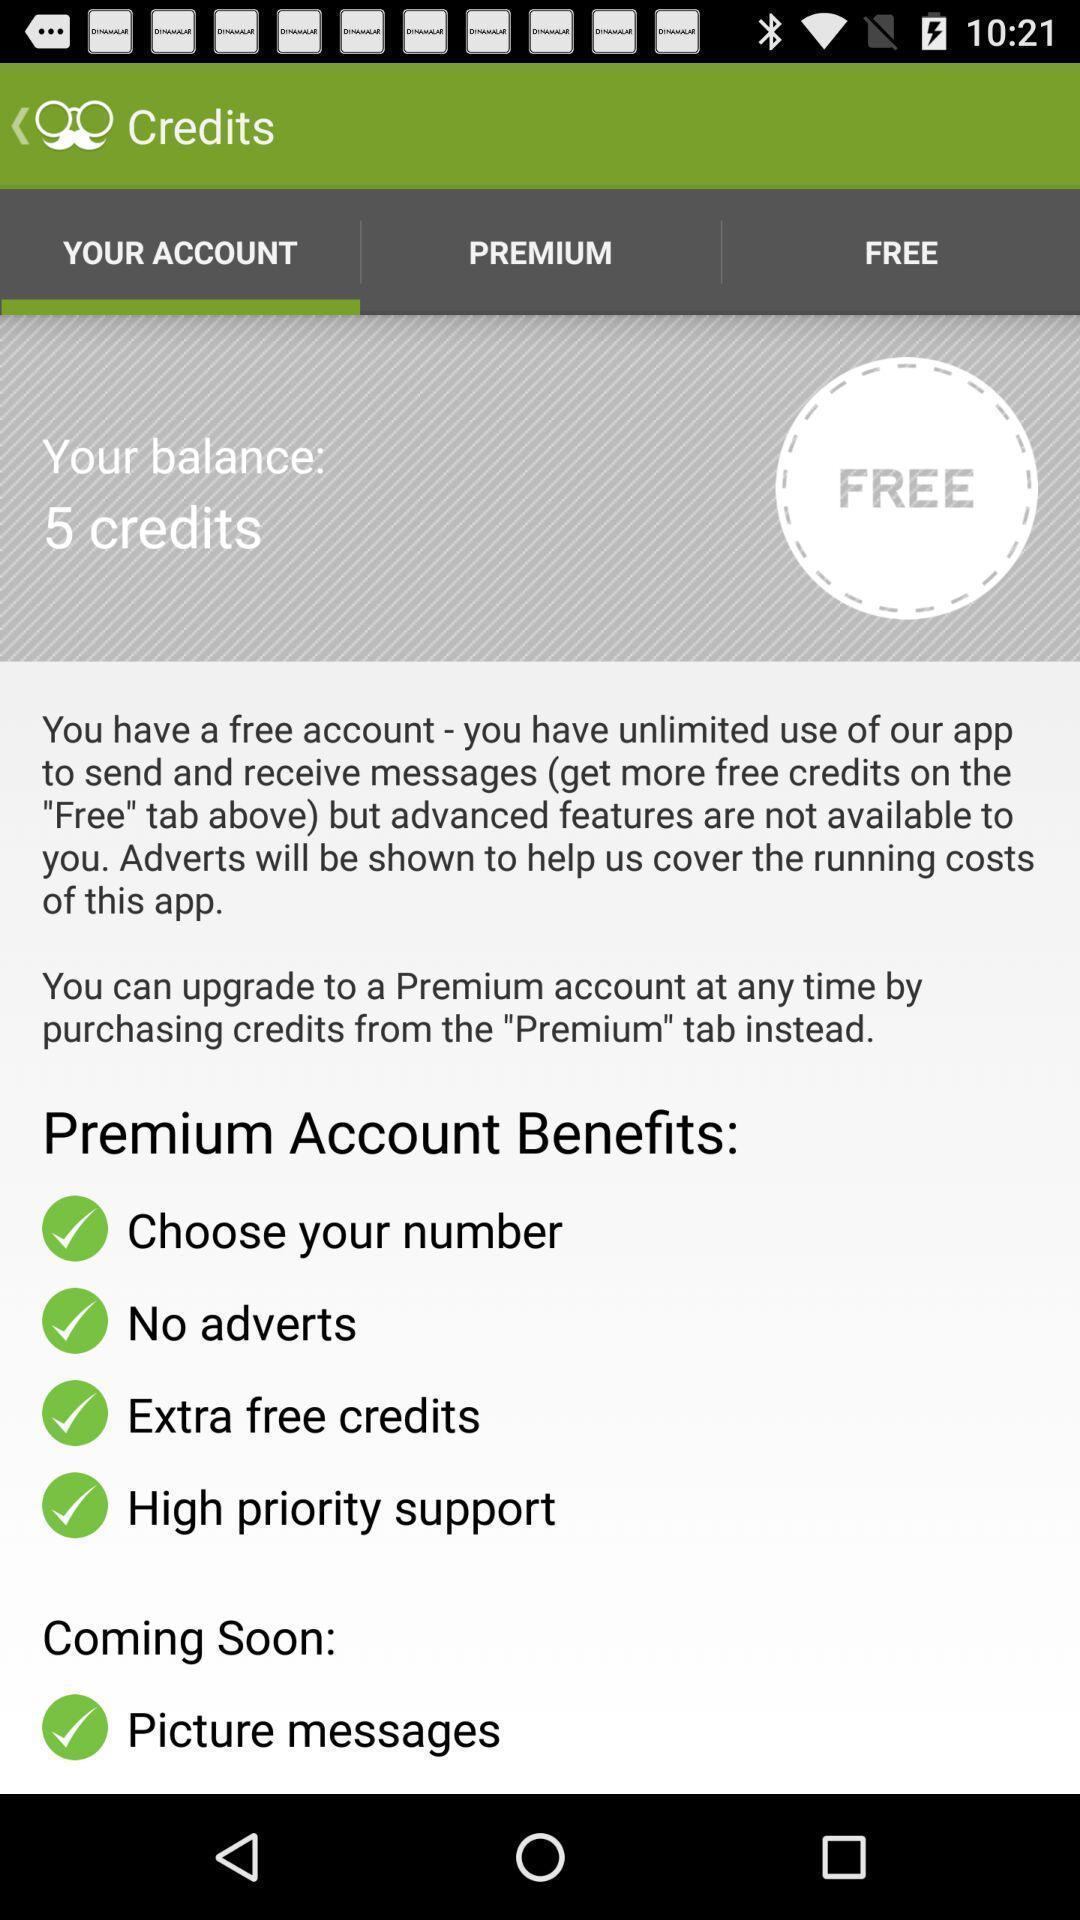Describe this image in words. Page displays benefits of premium account in app. 